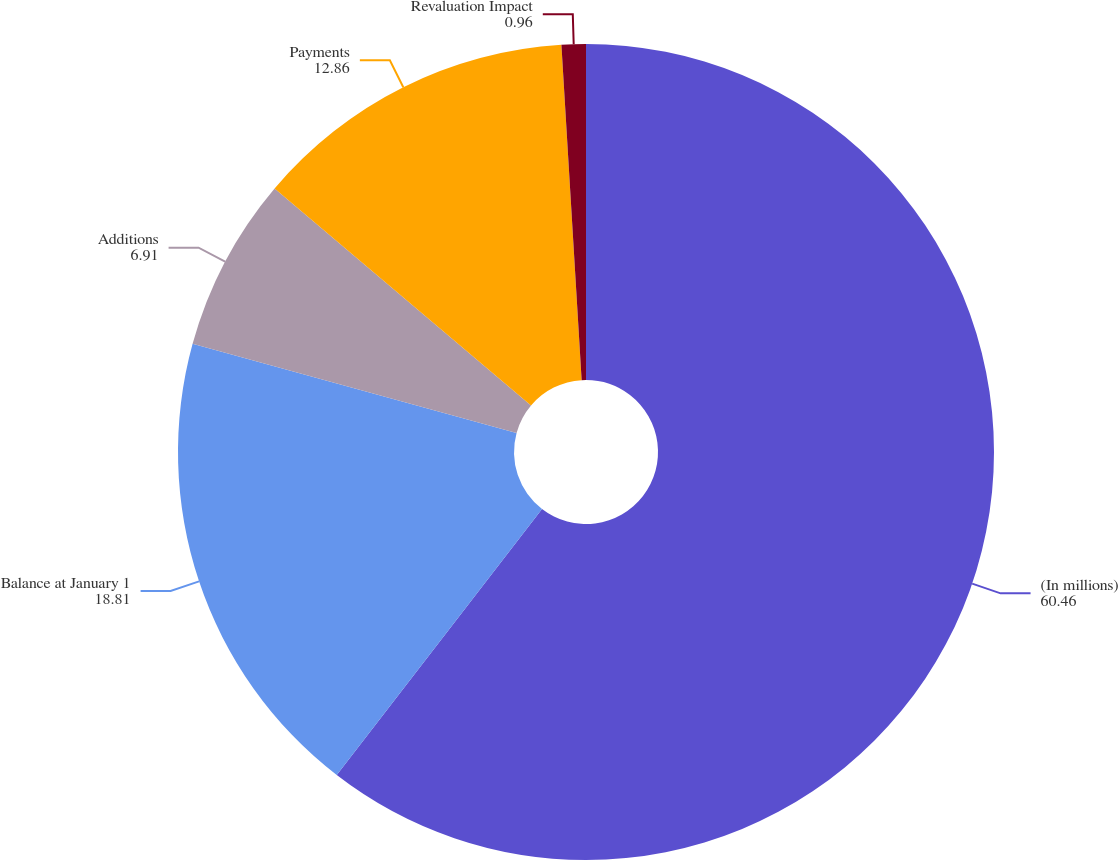<chart> <loc_0><loc_0><loc_500><loc_500><pie_chart><fcel>(In millions)<fcel>Balance at January 1<fcel>Additions<fcel>Payments<fcel>Revaluation Impact<nl><fcel>60.46%<fcel>18.81%<fcel>6.91%<fcel>12.86%<fcel>0.96%<nl></chart> 